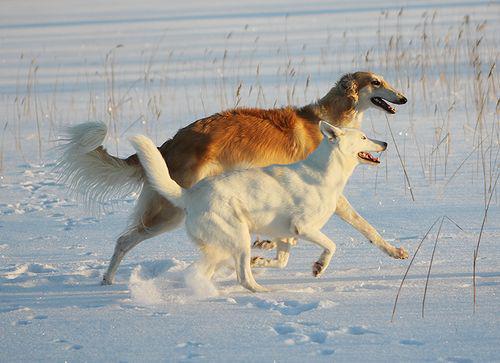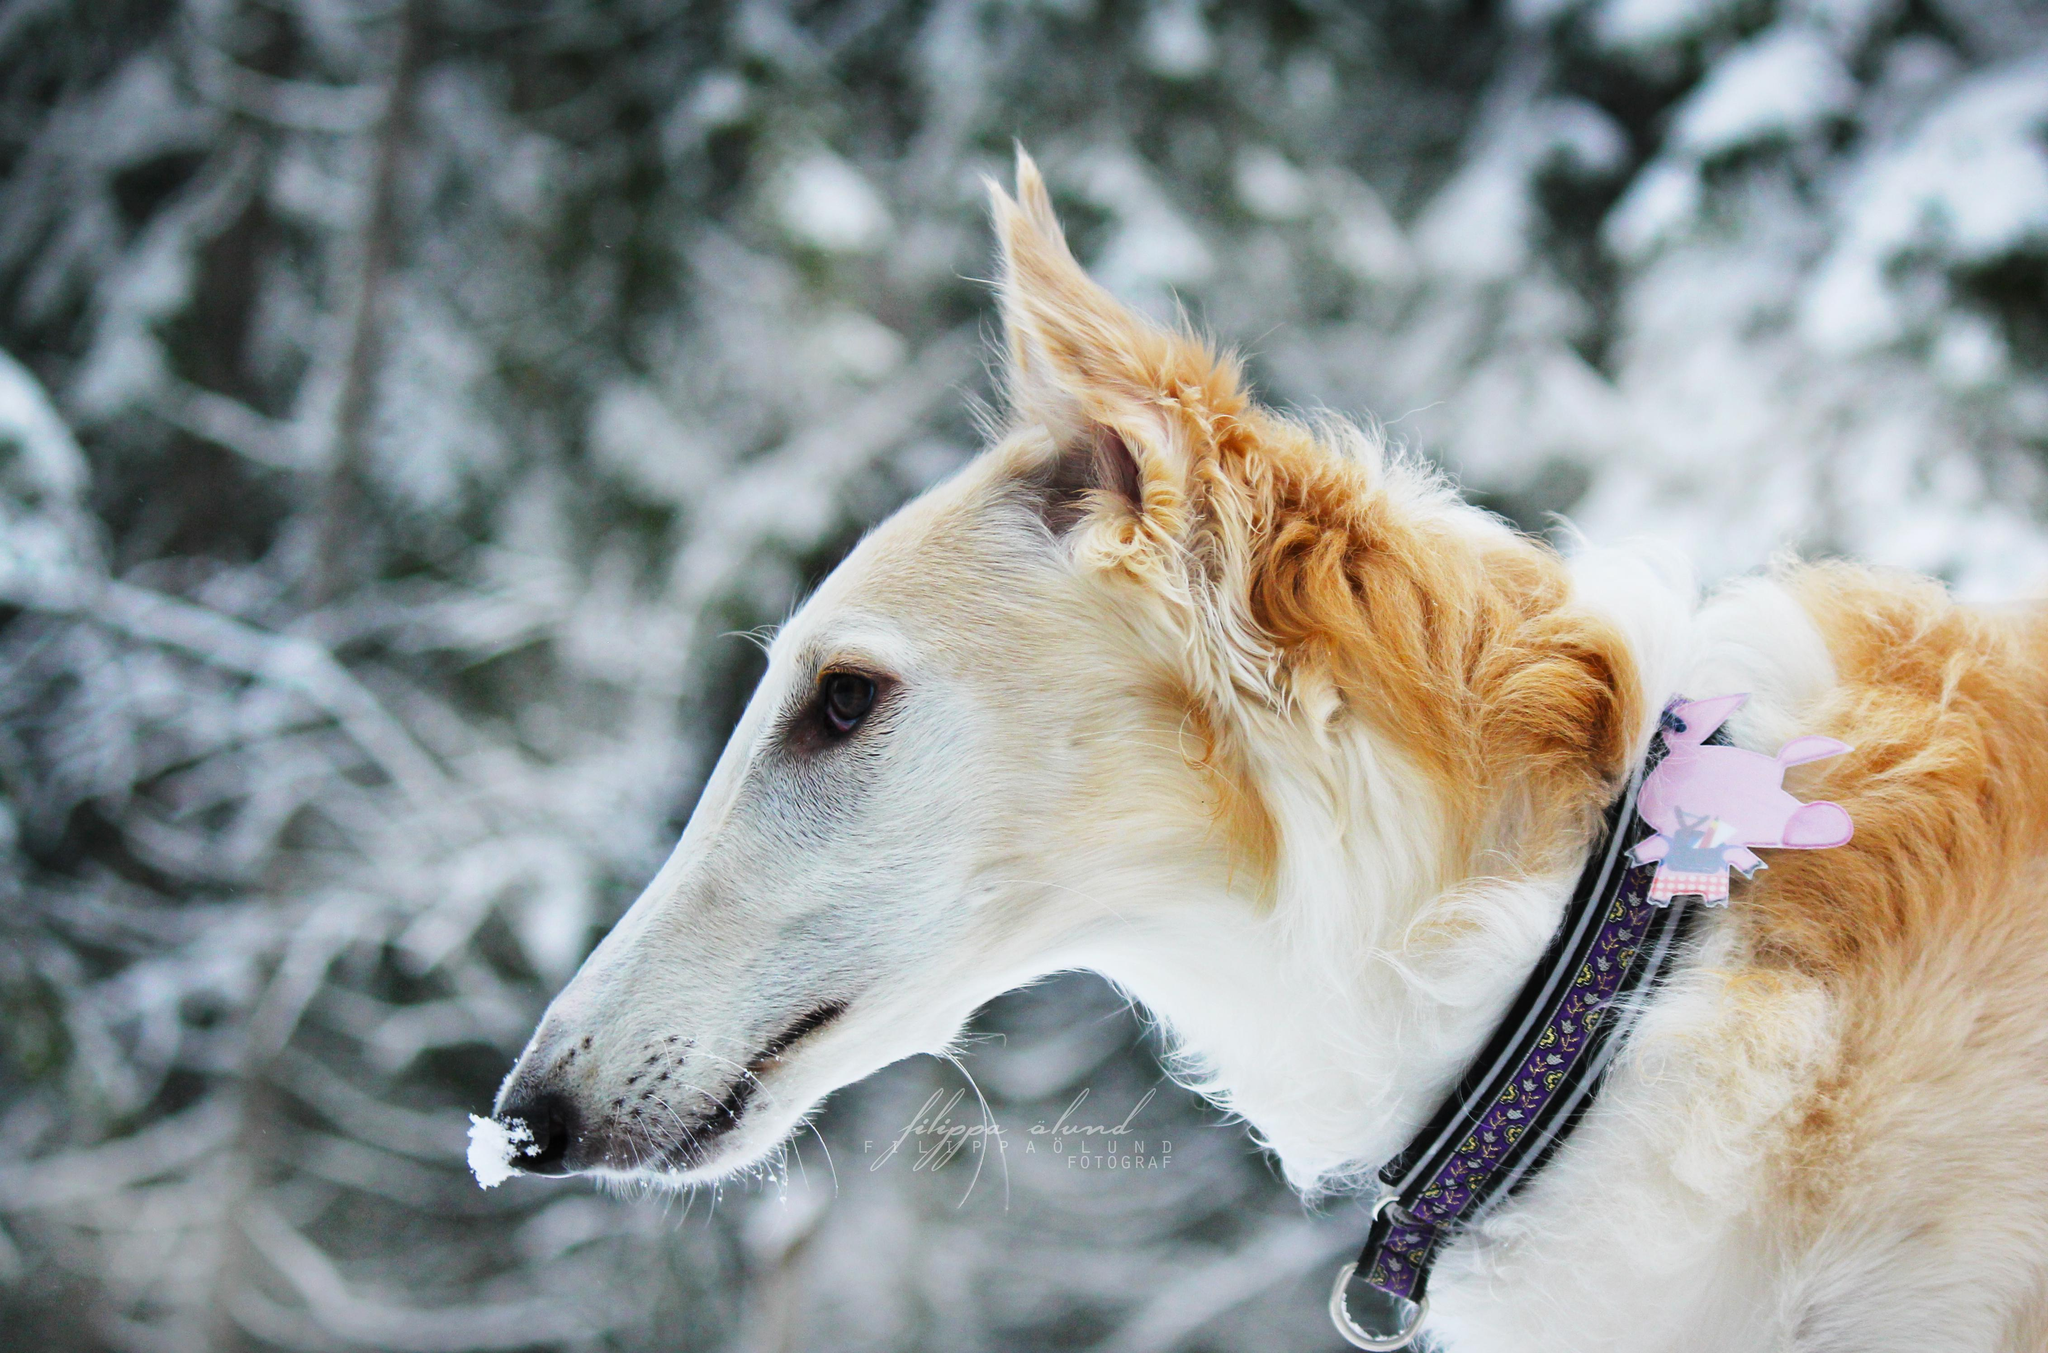The first image is the image on the left, the second image is the image on the right. Considering the images on both sides, is "There are three dogs and a woman" valid? Answer yes or no. No. The first image is the image on the left, the second image is the image on the right. Assess this claim about the two images: "One image is a wintry scene featuring a woman bundled up in a flowing garment with at least one hound on the left.". Correct or not? Answer yes or no. No. 